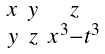Convert formula to latex. <formula><loc_0><loc_0><loc_500><loc_500>\begin{smallmatrix} x & y & z \\ y & z & x ^ { 3 } - t ^ { 3 } \end{smallmatrix}</formula> 